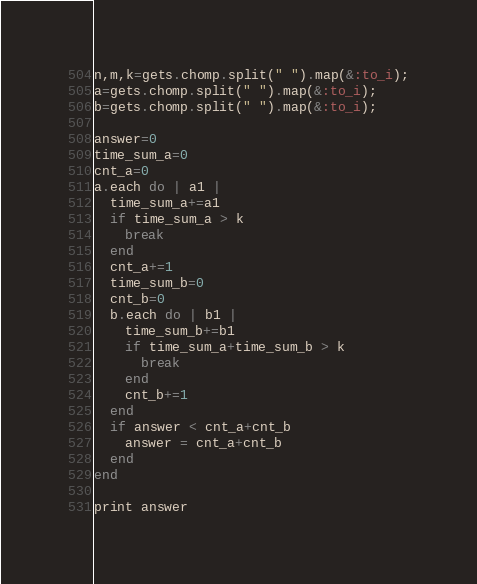Convert code to text. <code><loc_0><loc_0><loc_500><loc_500><_Ruby_>
n,m,k=gets.chomp.split(" ").map(&:to_i);
a=gets.chomp.split(" ").map(&:to_i);
b=gets.chomp.split(" ").map(&:to_i);

answer=0
time_sum_a=0
cnt_a=0
a.each do | a1 |
  time_sum_a+=a1
  if time_sum_a > k
    break
  end
  cnt_a+=1
  time_sum_b=0
  cnt_b=0
  b.each do | b1 |
    time_sum_b+=b1
    if time_sum_a+time_sum_b > k
      break
    end
    cnt_b+=1
  end
  if answer < cnt_a+cnt_b
    answer = cnt_a+cnt_b
  end
end

print answer
</code> 